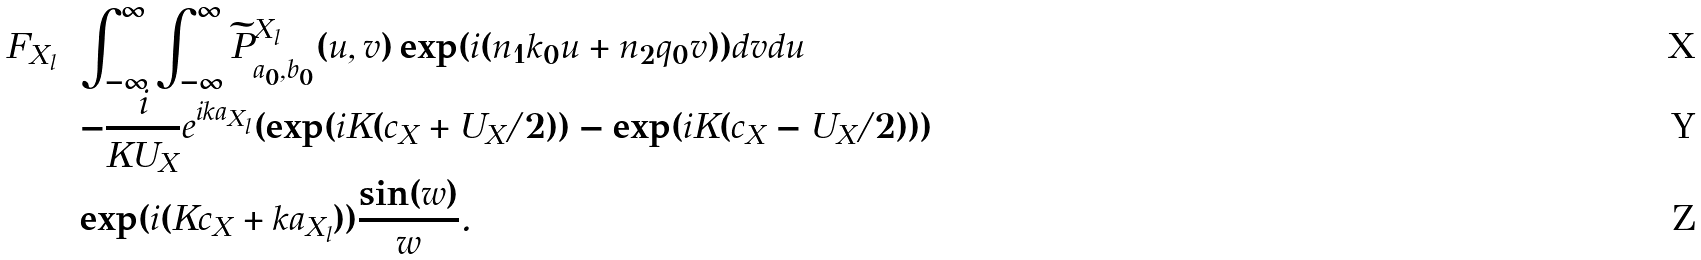Convert formula to latex. <formula><loc_0><loc_0><loc_500><loc_500>F _ { X _ { l } } & = \int _ { - \infty } ^ { \infty } \int _ { - \infty } ^ { \infty } \widetilde { P } ^ { X _ { l } } _ { a _ { 0 } , b _ { 0 } } ( u , v ) \exp ( i ( n _ { 1 } k _ { 0 } u + n _ { 2 } q _ { 0 } v ) ) d v d u \\ & = - \frac { i } { K U _ { X } } e ^ { i k a _ { X _ { l } } } ( \exp ( i K ( c _ { X } + U _ { X } / 2 ) ) - \exp ( i K ( c _ { X } - U _ { X } / 2 ) ) ) \\ & = \exp ( i ( K c _ { X } + k a _ { X _ { l } } ) ) \frac { \sin ( w ) } { w } .</formula> 